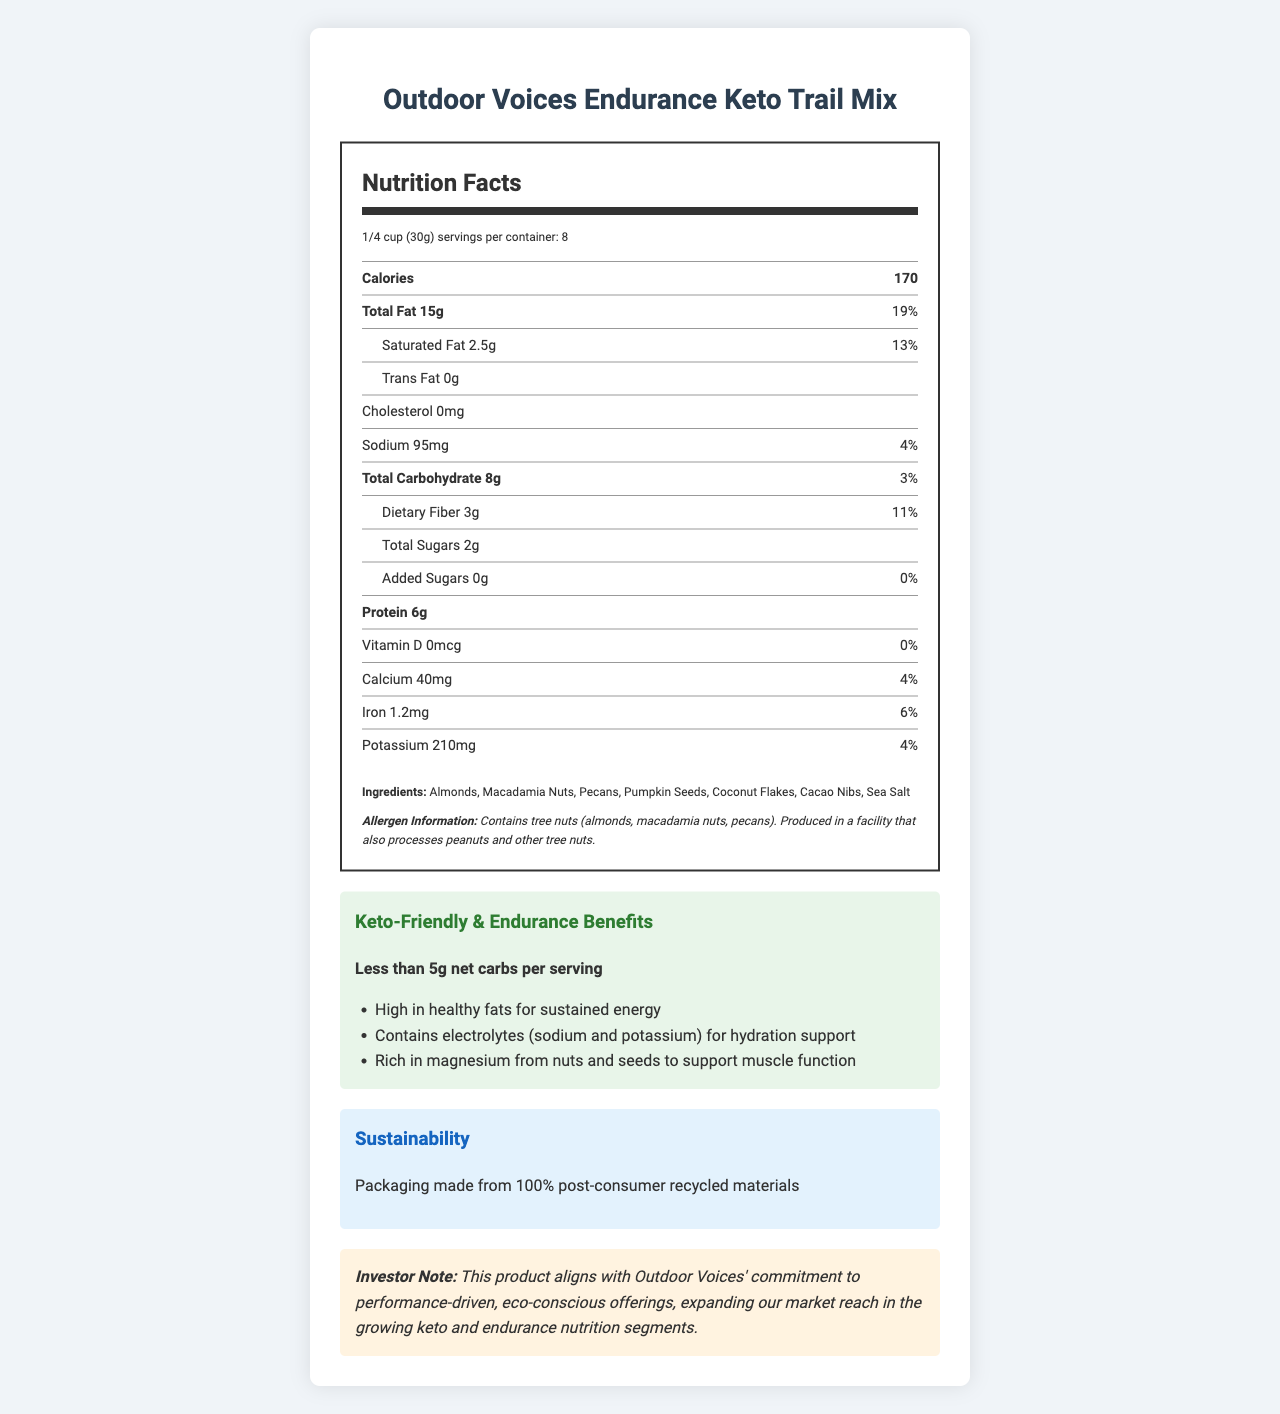what is the serving size? The serving size is stated in the serving information section at the beginning of the nutrition label.
Answer: 1/4 cup (30g) how many servings are in one container? The number of servings per container is mentioned in the same section as the serving size.
Answer: 8 how many calories are there per serving? The calories per serving are highlighted in bold in the nutrition label.
Answer: 170 what is the total fat content, and what percentage of the daily value does it represent? The total fat content and its daily value percentage are both listed in the nutrition label under the Total Fat section.
Answer: 15g, 19% how much dietary fiber does the trail mix contain per serving? The dietary fiber amount is found under the Total Carbohydrate section.
Answer: 3g what vitamin is not present in the trail mix? The label shows that Vitamin D amount is 0mcg with 0% daily value.
Answer: Vitamin D what are the main ingredients in this trail mix? The ingredients are listed at the bottom of the nutrition label.
Answer: Almonds, Macadamia Nuts, Pecans, Pumpkin Seeds, Coconut Flakes, Cacao Nibs, Sea Salt what allergens are present in this trail mix? The allergen information follows the ingredients list.
Answer: Contains tree nuts (almonds, macadamia nuts, pecans). Produced in a facility that also processes peanuts and other tree nuts. which of the following is not an endurance benefit of the trail mix? 
A. High in protein
B. High in healthy fats for sustained energy
C. Contains electrolytes for hydration support
D. Rich in magnesium to support muscle function The three benefits listed on the label are high in healthy fats for sustained energy, contains electrolytes (sodium and potassium) for hydration support, and rich in magnesium from nuts and seeds to support muscle function. High in protein is not mentioned as an endurance benefit.
Answer: A how many grams of trans fat are there in the trail mix? 
I. 0g
II. 2g
III. 15g
IV. 2.5g The trail mix contains 0g of trans fat, as specified under the Total Fat section.
Answer: I is this trail mix suitable for a keto diet? The keto-friendly claim states that the trail mix has less than 5g net carbs per serving, making it suitable for a keto diet.
Answer: Yes what are the sustainability features of the packaging? The sustainability section mentions this feature of the packaging.
Answer: Packaging made from 100% post-consumer recycled materials what does the investor note suggest about this product? This statement is in the investor note section of the document.
Answer: This product aligns with Outdoor Voices' commitment to performance-driven, eco-conscious offerings, expanding our market reach in the growing keto and endurance nutrition segments. what is the potassium amount per serving? The potassium amount is listed towards the end of the nutrition label.
Answer: 210mg does the trail mix contain any added sugars? It is stated that the trail mix has 0g of added sugars.
Answer: No what percentage of the daily value for iron does this trail mix provide? The daily value percentage for iron is noted in the nutrition label.
Answer: 6% what mineral supports muscle function according to the endurance benefits? The noted benefits include that the trail mix is rich in magnesium from nuts and seeds to support muscle function.
Answer: Magnesium what color is the background of the claims section? The claims section has a greenish background color according to the provided CSS style.
Answer: greenish (specifically #e8f5e9) what is the total carbohydrate content per serving? The total carbohydrate content is listed in bold in the nutrition label.
Answer: 8g describe the main idea of this document. The document is organized to give clear details on the nutritional content, health benefits, and eco-friendliness of the product along with an investor note on its alignment with market trends.
Answer: The document provides comprehensive nutrition facts, ingredients, and health benefits of Outdoor Voices' Endurance Keto Trail Mix, highlighting its suitability for a keto diet and endurance activities. It also emphasizes its eco-friendly packaging and relevance for investors interested in the performance-driven and eco-conscious products market. who is the contact person for more information about this product? The document does not provide contact information for further inquiries about the product.
Answer: Not enough information 